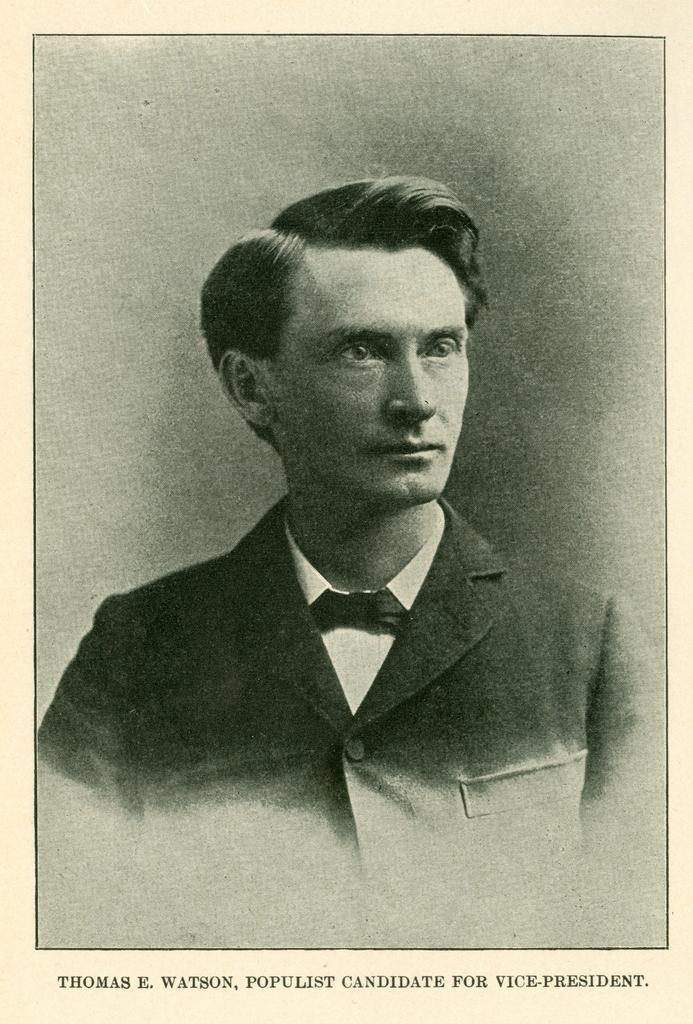In one or two sentences, can you explain what this image depicts? As we can see in the image there is a paper. On paper there is a man wearing black color jacket. 